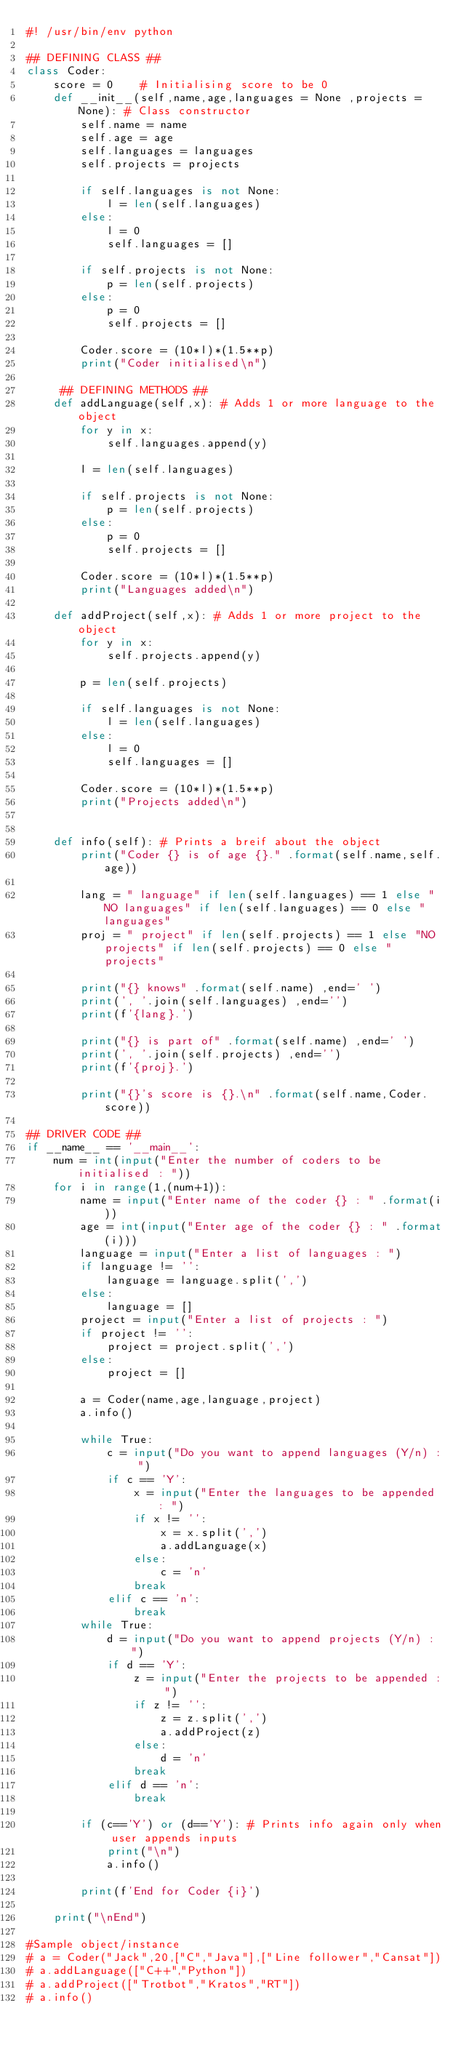<code> <loc_0><loc_0><loc_500><loc_500><_Python_>#! /usr/bin/env python

## DEFINING CLASS ##
class Coder:
    score = 0    # Initialising score to be 0
    def __init__(self,name,age,languages = None ,projects = None): # Class constructor
        self.name = name
        self.age = age
        self.languages = languages
        self.projects = projects
        
        if self.languages is not None:
            l = len(self.languages)
        else:
            l = 0
            self.languages = []
        
        if self.projects is not None:
            p = len(self.projects)
        else:
            p = 0
            self.projects = []

        Coder.score = (10*l)*(1.5**p)
        print("Coder initialised\n")

     ## DEFINING METHODS ##    
    def addLanguage(self,x): # Adds 1 or more language to the object
        for y in x:
            self.languages.append(y)

        l = len(self.languages)

        if self.projects is not None:
            p = len(self.projects)
        else:
            p = 0
            self.projects = []
        
        Coder.score = (10*l)*(1.5**p)
        print("Languages added\n")
    
    def addProject(self,x): # Adds 1 or more project to the object
        for y in x:
            self.projects.append(y)
        
        p = len(self.projects)

        if self.languages is not None:
            l = len(self.languages)
        else:
            l = 0
            self.languages = []

        Coder.score = (10*l)*(1.5**p)
        print("Projects added\n")
           

    def info(self): # Prints a breif about the object
        print("Coder {} is of age {}." .format(self.name,self.age))
        
        lang = " language" if len(self.languages) == 1 else "NO languages" if len(self.languages) == 0 else " languages"
        proj = " project" if len(self.projects) == 1 else "NO projects" if len(self.projects) == 0 else " projects"
        
        print("{} knows" .format(self.name) ,end=' ')
        print(', '.join(self.languages) ,end='')
        print(f'{lang}.')

        print("{} is part of" .format(self.name) ,end=' ')
        print(', '.join(self.projects) ,end='')
        print(f'{proj}.')
        
        print("{}'s score is {}.\n" .format(self.name,Coder.score))

## DRIVER CODE ##
if __name__ == '__main__':
    num = int(input("Enter the number of coders to be initialised : "))
    for i in range(1,(num+1)):
        name = input("Enter name of the coder {} : " .format(i))
        age = int(input("Enter age of the coder {} : " .format(i)))
        language = input("Enter a list of languages : ")
        if language != '':
            language = language.split(',')
        else:
            language = []
        project = input("Enter a list of projects : ")
        if project != '':
            project = project.split(',')
        else:
            project = []

        a = Coder(name,age,language,project)
        a.info()

        while True:
            c = input("Do you want to append languages (Y/n) : ")
            if c == 'Y':
                x = input("Enter the languages to be appended : ")
                if x != '':
                    x = x.split(',')
                    a.addLanguage(x)
                else:
                    c = 'n'
                break
            elif c == 'n':
                break
        while True:
            d = input("Do you want to append projects (Y/n) : ")
            if d == 'Y':
                z = input("Enter the projects to be appended : ")
                if z != '':
                    z = z.split(',')
                    a.addProject(z)
                else:
                    d = 'n'
                break
            elif d == 'n':
                break

        if (c=='Y') or (d=='Y'): # Prints info again only when user appends inputs
            print("\n")
            a.info()
        
        print(f'End for Coder {i}')

    print("\nEnd")

#Sample object/instance
# a = Coder("Jack",20,["C","Java"],["Line follower","Cansat"])
# a.addLanguage(["C++","Python"])
# a.addProject(["Trotbot","Kratos","RT"])
# a.info()</code> 